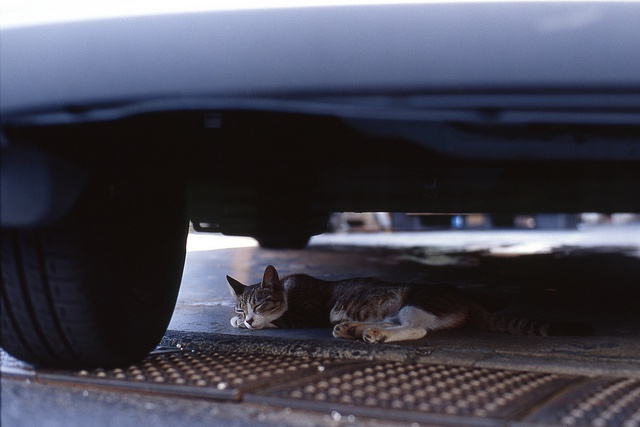Describe the objects in this image and their specific colors. I can see car in white, black, gray, darkgray, and navy tones and cat in white, black, gray, and darkgray tones in this image. 